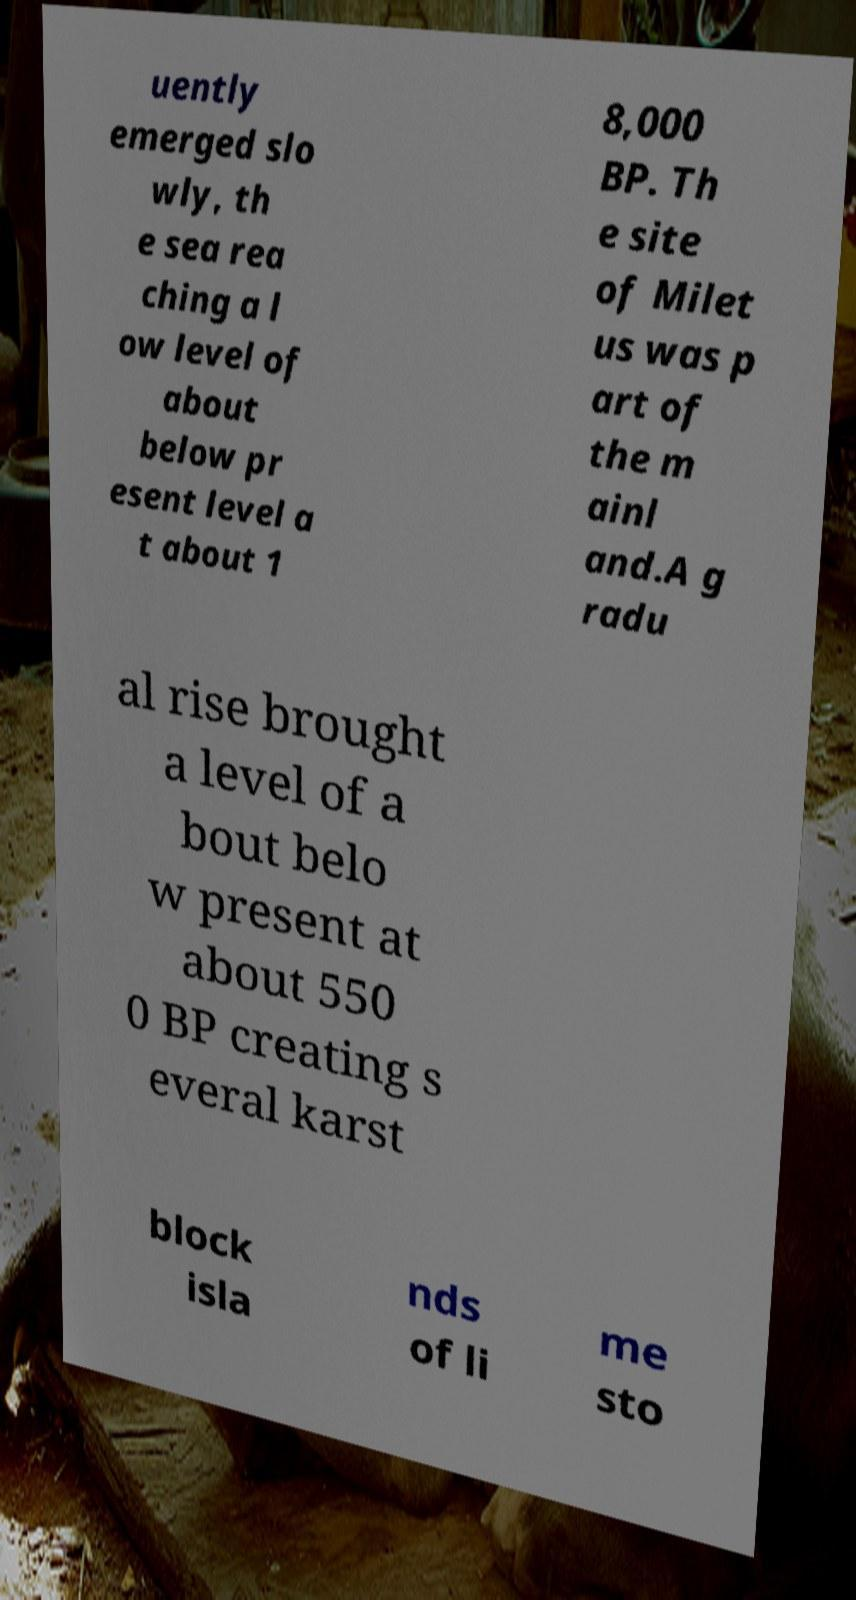For documentation purposes, I need the text within this image transcribed. Could you provide that? uently emerged slo wly, th e sea rea ching a l ow level of about below pr esent level a t about 1 8,000 BP. Th e site of Milet us was p art of the m ainl and.A g radu al rise brought a level of a bout belo w present at about 550 0 BP creating s everal karst block isla nds of li me sto 